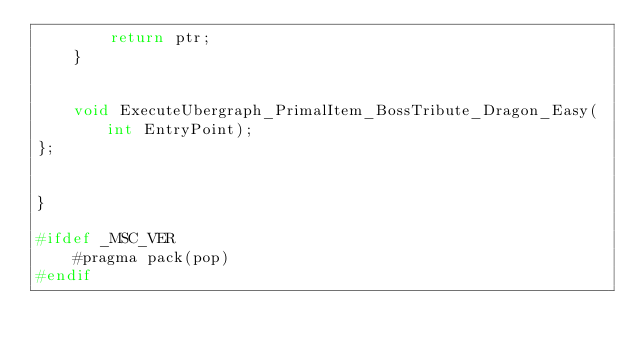Convert code to text. <code><loc_0><loc_0><loc_500><loc_500><_C++_>		return ptr;
	}


	void ExecuteUbergraph_PrimalItem_BossTribute_Dragon_Easy(int EntryPoint);
};


}

#ifdef _MSC_VER
	#pragma pack(pop)
#endif
</code> 